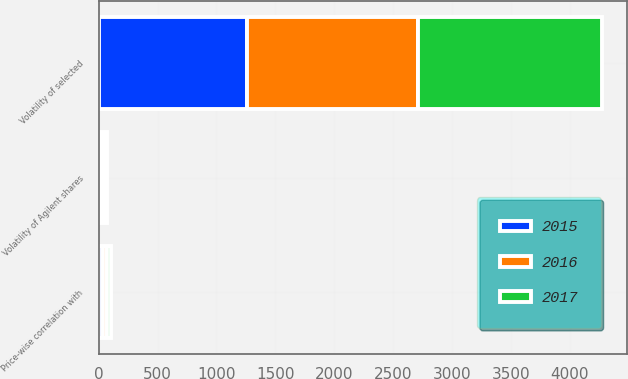Convert chart to OTSL. <chart><loc_0><loc_0><loc_500><loc_500><stacked_bar_chart><ecel><fcel>Volatility of Agilent shares<fcel>Volatility of selected<fcel>Price-wise correlation with<nl><fcel>2017<fcel>23<fcel>1563<fcel>36<nl><fcel>2016<fcel>24<fcel>1450<fcel>35<nl><fcel>2015<fcel>25<fcel>1257<fcel>37<nl></chart> 